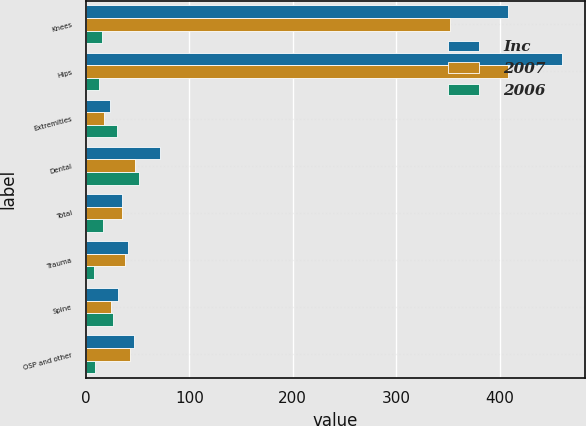Convert chart to OTSL. <chart><loc_0><loc_0><loc_500><loc_500><stacked_bar_chart><ecel><fcel>Knees<fcel>Hips<fcel>Extremities<fcel>Dental<fcel>Total<fcel>Trauma<fcel>Spine<fcel>OSP and other<nl><fcel>Inc<fcel>407.8<fcel>459.9<fcel>23.2<fcel>71.3<fcel>34.7<fcel>41.1<fcel>31.2<fcel>46.5<nl><fcel>2007<fcel>352.2<fcel>408.3<fcel>17.9<fcel>47.2<fcel>34.7<fcel>38.2<fcel>24.8<fcel>42.5<nl><fcel>2006<fcel>16<fcel>13<fcel>30<fcel>51<fcel>17<fcel>8<fcel>26<fcel>9<nl></chart> 